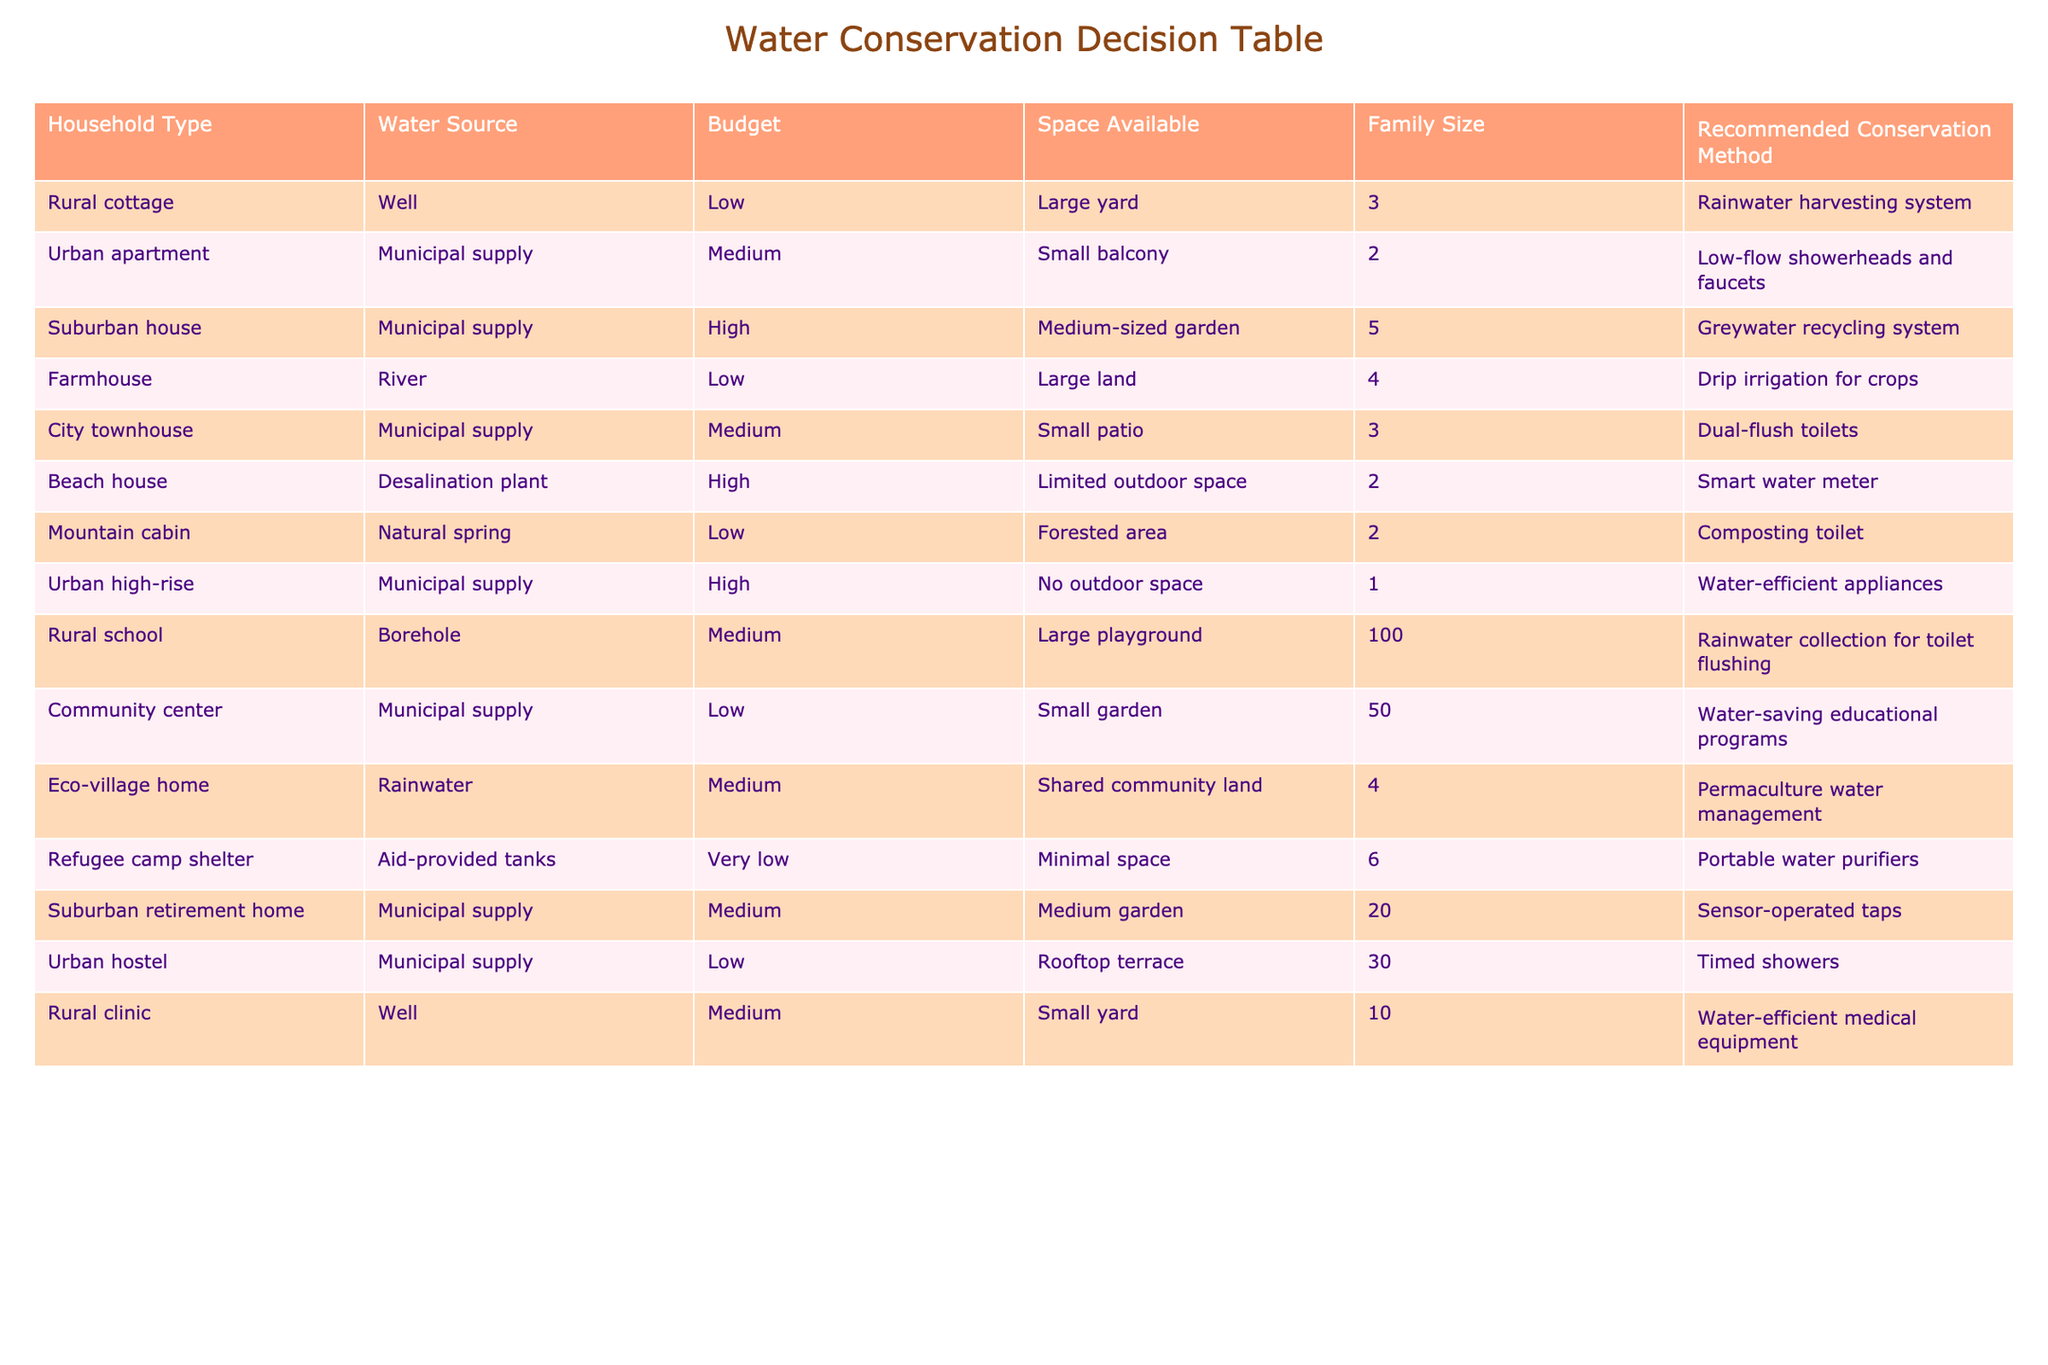What is the recommended conservation method for a rural cottage with a well? From the table, the entry for "Rural cottage" lists "Rainwater harvesting system" under the Recommended Conservation Method column.
Answer: Rainwater harvesting system Which household type has the highest family size and what is the recommended conservation method? The entry for "Refugee camp shelter" has the highest family size listed at 6. The corresponding recommended conservation method is "Portable water purifiers."
Answer: Portable water purifiers Is there a household type with a low budget that recommends greywater recycling? Referring to the table, none of the household types listed under a low budget have greywater recycling as a recommendation. The exclusive recommendation for greywater recycling is for the suburban house with a high budget.
Answer: No What is the average family size for households that utilize municipal supply? There are six entries with municipal supply: Urban apartment (2), Suburban house (5), City townhouse (3), Urban high-rise (1), Community center (50), and Suburban retirement home (20). Adding these gives a total of 81 and there are six households, so the average is 81/6 = 13.5.
Answer: 13.5 Which conservation method is recommended for the farmhouse, and how does it compare to that of the urban apartment? For the farmhouse, the recommended method is "Drip irrigation for crops," while for the urban apartment, it is "Low-flow showerheads and faucets." Both methods cater to different household needs based on their settings, but the farmhouse method is more focused on agricultural efficiency, while the apartment method aims for water savings indoors.
Answer: Drip irrigation for crops vs. Low-flow showerheads and faucets How many household types suggest rainwater-related methods? The table lists two entries that suggest rainwater-related methods: "Rainwater harvesting system" for the rural cottage and "Rainwater collection for toilet flushing" for the rural school. Therefore, there are two household types related to rainwater conservation.
Answer: 2 Is it true that the beach house has a high budget and limited outdoor space? Checking the data, the beach house is indeed listed under high budget and has limited outdoor space as specified in the description. Thus, this statement is true.
Answer: Yes What is the recommended conservation method for the eco-village home, and how is it relevant to the household type? The eco-village home recommends "Permaculture water management," which is relevant as it reflects an integrated approach to conserve water while working within community land and eco-friendly practices, encouraging sustainable water use in shared spaces.
Answer: Permaculture water management 